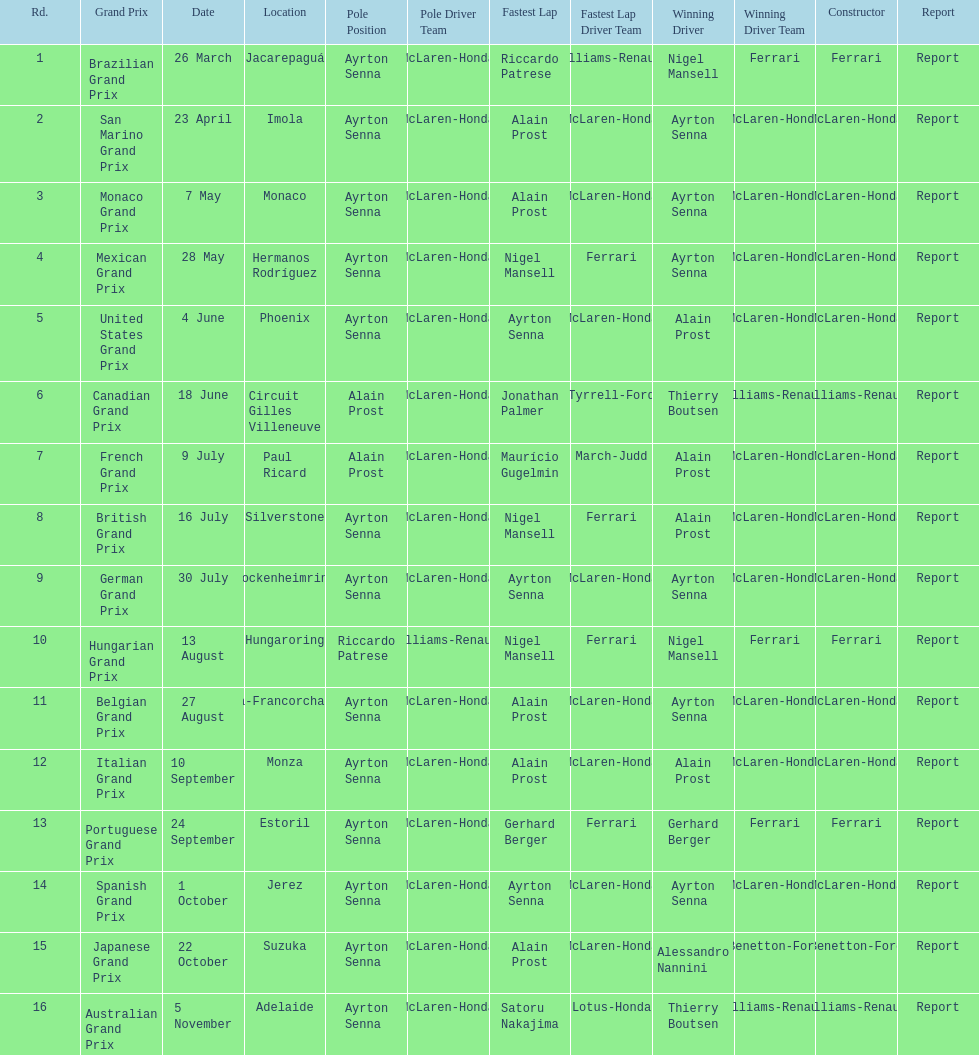How many races occurred before alain prost won a pole position? 5. 